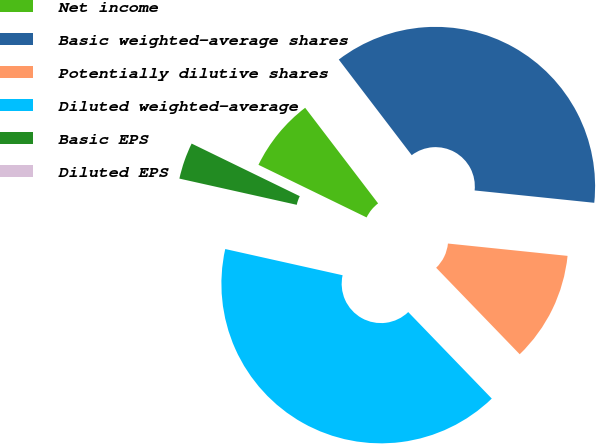Convert chart to OTSL. <chart><loc_0><loc_0><loc_500><loc_500><pie_chart><fcel>Net income<fcel>Basic weighted-average shares<fcel>Potentially dilutive shares<fcel>Diluted weighted-average<fcel>Basic EPS<fcel>Diluted EPS<nl><fcel>7.42%<fcel>37.01%<fcel>11.14%<fcel>40.72%<fcel>3.71%<fcel>0.0%<nl></chart> 